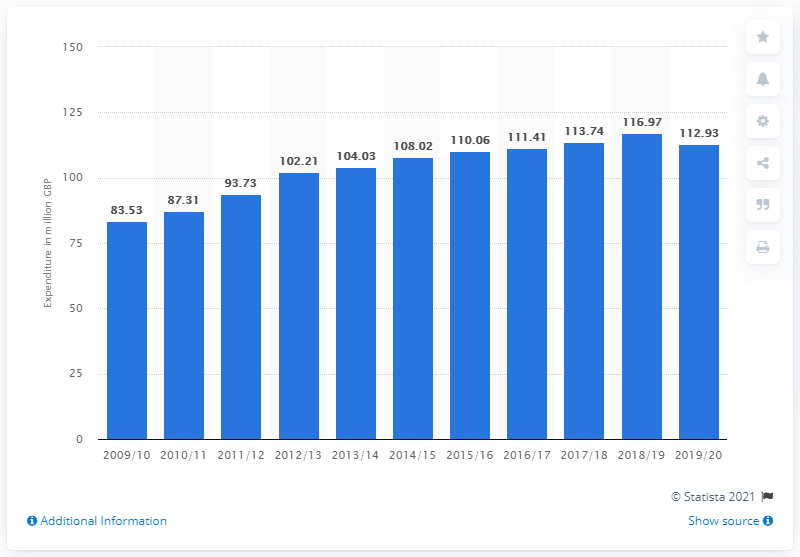Mention a couple of crucial points in this snapshot. The previous financial year, the UK spent 116.97 on pensions. In the 2019/2020 fiscal year, the UK government spent a total of 112.93 million pounds on pensions. 